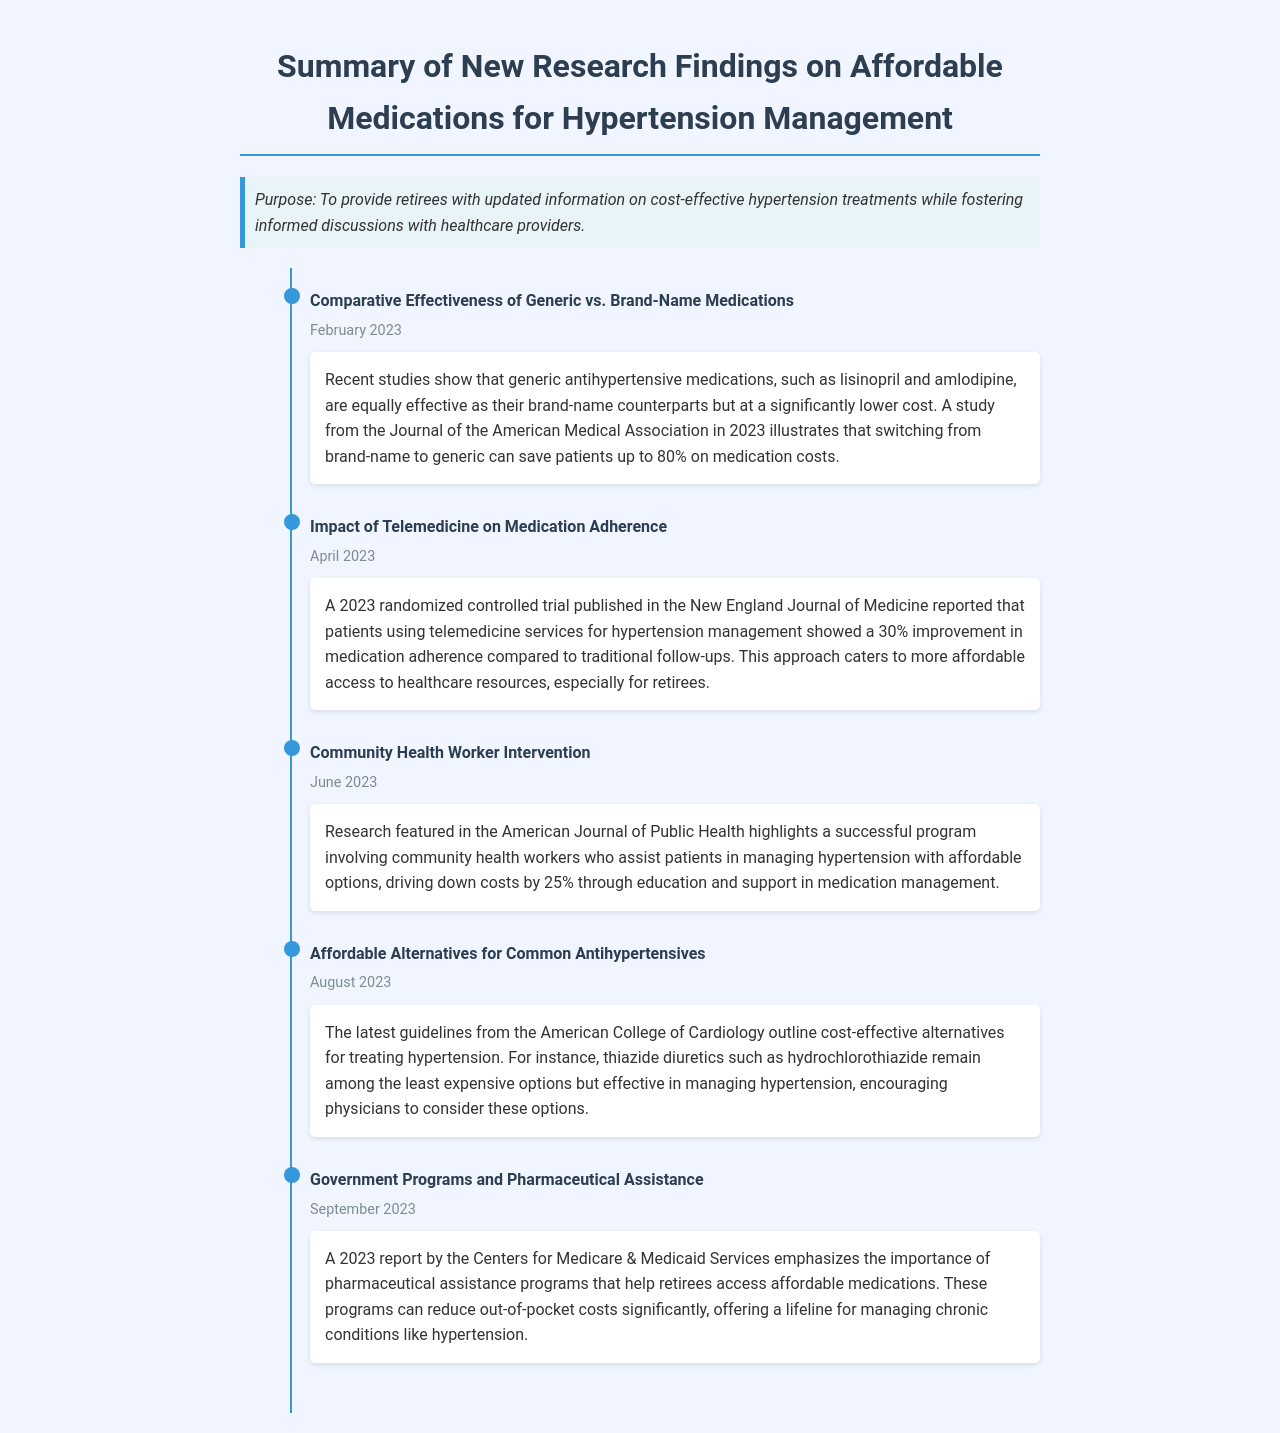What is the purpose of the document? The purpose is to provide retirees with updated information on cost-effective hypertension treatments while fostering informed discussions with healthcare providers.
Answer: To provide retirees with updated information on cost-effective hypertension treatments while fostering informed discussions with healthcare providers What medication is compared to brand-name counterparts in the February 2023 research? The entry mentions specific antihypertensive medications that are generic and equally effective as brand-name ones, such as lisinopril and amlodipine.
Answer: Lisinopril and amlodipine By what percentage did telemedicine improve medication adherence in April 2023? The document states that there was a 30% improvement in medication adherence for patients using telemedicine services.
Answer: 30% What was the cost reduction percentage achieved through community health worker intervention in June 2023? The research highlighted a cost reduction achieved through education and support in medication management by 25%.
Answer: 25% What is one of the least expensive options for managing hypertension according to the August 2023 guidelines? The guidelines specify thiazide diuretics, mentioning hydrochlorothiazide as one of the least expensive and effective options.
Answer: Hydrochlorothiazide What organization emphasized the importance of pharmaceutical assistance programs in September 2023? The document notes that the Centers for Medicare & Medicaid Services issued a report on this topic.
Answer: Centers for Medicare & Medicaid Services When was the study published that reported the effectiveness of generic antihypertensive medications? The study was published in February 2023 according to the timeline provided in the document.
Answer: February 2023 What type of journal published the study on community health worker intervention? The research was featured in the American Journal of Public Health.
Answer: American Journal of Public Health 